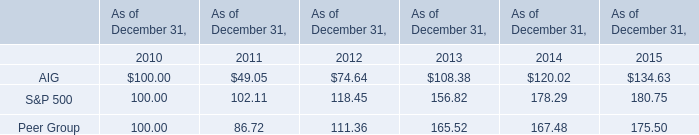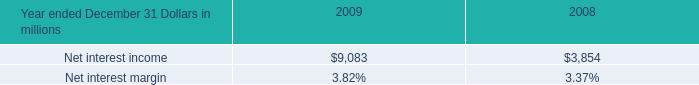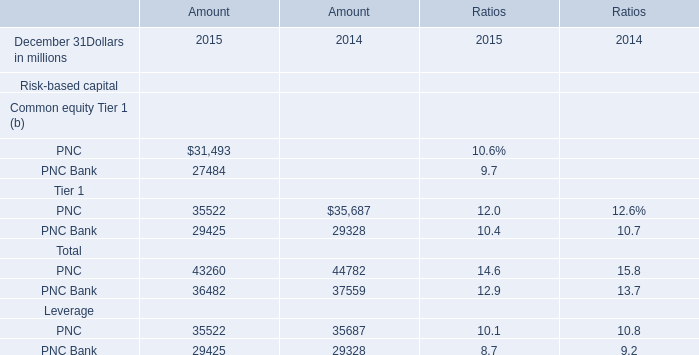what was the percentage change in the asset management revenue from 2008 to 2009 
Computations: (172 / 686)
Answer: 0.25073. 